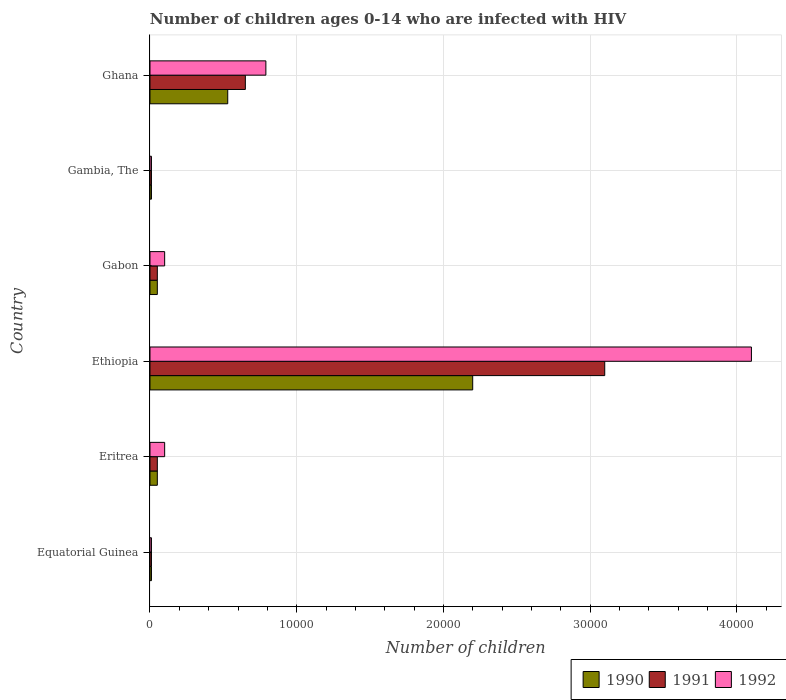How many different coloured bars are there?
Provide a short and direct response. 3. How many bars are there on the 3rd tick from the top?
Ensure brevity in your answer.  3. How many bars are there on the 6th tick from the bottom?
Your answer should be very brief. 3. What is the label of the 6th group of bars from the top?
Ensure brevity in your answer.  Equatorial Guinea. What is the number of HIV infected children in 1990 in Equatorial Guinea?
Give a very brief answer. 100. Across all countries, what is the maximum number of HIV infected children in 1992?
Your answer should be compact. 4.10e+04. Across all countries, what is the minimum number of HIV infected children in 1991?
Offer a terse response. 100. In which country was the number of HIV infected children in 1991 maximum?
Keep it short and to the point. Ethiopia. In which country was the number of HIV infected children in 1990 minimum?
Make the answer very short. Equatorial Guinea. What is the total number of HIV infected children in 1990 in the graph?
Provide a short and direct response. 2.85e+04. What is the difference between the number of HIV infected children in 1992 in Ethiopia and that in Ghana?
Give a very brief answer. 3.31e+04. What is the difference between the number of HIV infected children in 1992 in Gambia, The and the number of HIV infected children in 1991 in Ethiopia?
Ensure brevity in your answer.  -3.09e+04. What is the average number of HIV infected children in 1992 per country?
Your answer should be compact. 8516.67. What is the difference between the number of HIV infected children in 1990 and number of HIV infected children in 1992 in Equatorial Guinea?
Offer a terse response. 0. In how many countries, is the number of HIV infected children in 1991 greater than 26000 ?
Keep it short and to the point. 1. What is the ratio of the number of HIV infected children in 1990 in Equatorial Guinea to that in Eritrea?
Your answer should be very brief. 0.2. Is the number of HIV infected children in 1990 in Equatorial Guinea less than that in Gabon?
Ensure brevity in your answer.  Yes. What is the difference between the highest and the second highest number of HIV infected children in 1991?
Provide a succinct answer. 2.45e+04. What is the difference between the highest and the lowest number of HIV infected children in 1992?
Offer a terse response. 4.09e+04. Is the sum of the number of HIV infected children in 1990 in Eritrea and Ghana greater than the maximum number of HIV infected children in 1992 across all countries?
Give a very brief answer. No. How many bars are there?
Provide a succinct answer. 18. Are all the bars in the graph horizontal?
Make the answer very short. Yes. How many countries are there in the graph?
Your answer should be compact. 6. What is the difference between two consecutive major ticks on the X-axis?
Provide a short and direct response. 10000. Are the values on the major ticks of X-axis written in scientific E-notation?
Keep it short and to the point. No. Does the graph contain grids?
Your response must be concise. Yes. How are the legend labels stacked?
Give a very brief answer. Horizontal. What is the title of the graph?
Ensure brevity in your answer.  Number of children ages 0-14 who are infected with HIV. Does "2002" appear as one of the legend labels in the graph?
Your response must be concise. No. What is the label or title of the X-axis?
Ensure brevity in your answer.  Number of children. What is the label or title of the Y-axis?
Make the answer very short. Country. What is the Number of children of 1990 in Equatorial Guinea?
Provide a succinct answer. 100. What is the Number of children in 1992 in Equatorial Guinea?
Keep it short and to the point. 100. What is the Number of children in 1991 in Eritrea?
Offer a terse response. 500. What is the Number of children in 1990 in Ethiopia?
Give a very brief answer. 2.20e+04. What is the Number of children of 1991 in Ethiopia?
Offer a terse response. 3.10e+04. What is the Number of children in 1992 in Ethiopia?
Give a very brief answer. 4.10e+04. What is the Number of children in 1990 in Gabon?
Your response must be concise. 500. What is the Number of children in 1992 in Gabon?
Your response must be concise. 1000. What is the Number of children of 1990 in Gambia, The?
Give a very brief answer. 100. What is the Number of children in 1991 in Gambia, The?
Your answer should be compact. 100. What is the Number of children of 1992 in Gambia, The?
Provide a succinct answer. 100. What is the Number of children in 1990 in Ghana?
Give a very brief answer. 5300. What is the Number of children in 1991 in Ghana?
Keep it short and to the point. 6500. What is the Number of children of 1992 in Ghana?
Make the answer very short. 7900. Across all countries, what is the maximum Number of children in 1990?
Your answer should be very brief. 2.20e+04. Across all countries, what is the maximum Number of children of 1991?
Keep it short and to the point. 3.10e+04. Across all countries, what is the maximum Number of children of 1992?
Your answer should be compact. 4.10e+04. Across all countries, what is the minimum Number of children of 1990?
Offer a very short reply. 100. Across all countries, what is the minimum Number of children in 1991?
Ensure brevity in your answer.  100. Across all countries, what is the minimum Number of children of 1992?
Provide a succinct answer. 100. What is the total Number of children of 1990 in the graph?
Your answer should be compact. 2.85e+04. What is the total Number of children of 1991 in the graph?
Make the answer very short. 3.87e+04. What is the total Number of children of 1992 in the graph?
Provide a short and direct response. 5.11e+04. What is the difference between the Number of children of 1990 in Equatorial Guinea and that in Eritrea?
Offer a very short reply. -400. What is the difference between the Number of children of 1991 in Equatorial Guinea and that in Eritrea?
Offer a terse response. -400. What is the difference between the Number of children of 1992 in Equatorial Guinea and that in Eritrea?
Your response must be concise. -900. What is the difference between the Number of children of 1990 in Equatorial Guinea and that in Ethiopia?
Give a very brief answer. -2.19e+04. What is the difference between the Number of children in 1991 in Equatorial Guinea and that in Ethiopia?
Provide a short and direct response. -3.09e+04. What is the difference between the Number of children in 1992 in Equatorial Guinea and that in Ethiopia?
Offer a very short reply. -4.09e+04. What is the difference between the Number of children in 1990 in Equatorial Guinea and that in Gabon?
Make the answer very short. -400. What is the difference between the Number of children of 1991 in Equatorial Guinea and that in Gabon?
Your answer should be compact. -400. What is the difference between the Number of children in 1992 in Equatorial Guinea and that in Gabon?
Offer a terse response. -900. What is the difference between the Number of children in 1990 in Equatorial Guinea and that in Gambia, The?
Ensure brevity in your answer.  0. What is the difference between the Number of children of 1991 in Equatorial Guinea and that in Gambia, The?
Your answer should be compact. 0. What is the difference between the Number of children in 1990 in Equatorial Guinea and that in Ghana?
Keep it short and to the point. -5200. What is the difference between the Number of children in 1991 in Equatorial Guinea and that in Ghana?
Provide a short and direct response. -6400. What is the difference between the Number of children in 1992 in Equatorial Guinea and that in Ghana?
Offer a very short reply. -7800. What is the difference between the Number of children of 1990 in Eritrea and that in Ethiopia?
Your answer should be compact. -2.15e+04. What is the difference between the Number of children in 1991 in Eritrea and that in Ethiopia?
Offer a terse response. -3.05e+04. What is the difference between the Number of children in 1992 in Eritrea and that in Ethiopia?
Offer a very short reply. -4.00e+04. What is the difference between the Number of children of 1992 in Eritrea and that in Gabon?
Provide a short and direct response. 0. What is the difference between the Number of children in 1991 in Eritrea and that in Gambia, The?
Provide a short and direct response. 400. What is the difference between the Number of children of 1992 in Eritrea and that in Gambia, The?
Your answer should be very brief. 900. What is the difference between the Number of children of 1990 in Eritrea and that in Ghana?
Provide a succinct answer. -4800. What is the difference between the Number of children of 1991 in Eritrea and that in Ghana?
Provide a succinct answer. -6000. What is the difference between the Number of children in 1992 in Eritrea and that in Ghana?
Offer a very short reply. -6900. What is the difference between the Number of children of 1990 in Ethiopia and that in Gabon?
Ensure brevity in your answer.  2.15e+04. What is the difference between the Number of children of 1991 in Ethiopia and that in Gabon?
Ensure brevity in your answer.  3.05e+04. What is the difference between the Number of children in 1990 in Ethiopia and that in Gambia, The?
Provide a short and direct response. 2.19e+04. What is the difference between the Number of children in 1991 in Ethiopia and that in Gambia, The?
Your response must be concise. 3.09e+04. What is the difference between the Number of children in 1992 in Ethiopia and that in Gambia, The?
Your answer should be very brief. 4.09e+04. What is the difference between the Number of children in 1990 in Ethiopia and that in Ghana?
Your response must be concise. 1.67e+04. What is the difference between the Number of children in 1991 in Ethiopia and that in Ghana?
Make the answer very short. 2.45e+04. What is the difference between the Number of children of 1992 in Ethiopia and that in Ghana?
Provide a short and direct response. 3.31e+04. What is the difference between the Number of children of 1990 in Gabon and that in Gambia, The?
Your answer should be very brief. 400. What is the difference between the Number of children in 1992 in Gabon and that in Gambia, The?
Your response must be concise. 900. What is the difference between the Number of children in 1990 in Gabon and that in Ghana?
Ensure brevity in your answer.  -4800. What is the difference between the Number of children of 1991 in Gabon and that in Ghana?
Offer a very short reply. -6000. What is the difference between the Number of children in 1992 in Gabon and that in Ghana?
Provide a succinct answer. -6900. What is the difference between the Number of children in 1990 in Gambia, The and that in Ghana?
Make the answer very short. -5200. What is the difference between the Number of children of 1991 in Gambia, The and that in Ghana?
Offer a very short reply. -6400. What is the difference between the Number of children in 1992 in Gambia, The and that in Ghana?
Offer a very short reply. -7800. What is the difference between the Number of children of 1990 in Equatorial Guinea and the Number of children of 1991 in Eritrea?
Keep it short and to the point. -400. What is the difference between the Number of children of 1990 in Equatorial Guinea and the Number of children of 1992 in Eritrea?
Provide a succinct answer. -900. What is the difference between the Number of children of 1991 in Equatorial Guinea and the Number of children of 1992 in Eritrea?
Make the answer very short. -900. What is the difference between the Number of children of 1990 in Equatorial Guinea and the Number of children of 1991 in Ethiopia?
Offer a terse response. -3.09e+04. What is the difference between the Number of children in 1990 in Equatorial Guinea and the Number of children in 1992 in Ethiopia?
Your answer should be very brief. -4.09e+04. What is the difference between the Number of children of 1991 in Equatorial Guinea and the Number of children of 1992 in Ethiopia?
Offer a very short reply. -4.09e+04. What is the difference between the Number of children of 1990 in Equatorial Guinea and the Number of children of 1991 in Gabon?
Keep it short and to the point. -400. What is the difference between the Number of children of 1990 in Equatorial Guinea and the Number of children of 1992 in Gabon?
Keep it short and to the point. -900. What is the difference between the Number of children of 1991 in Equatorial Guinea and the Number of children of 1992 in Gabon?
Keep it short and to the point. -900. What is the difference between the Number of children of 1991 in Equatorial Guinea and the Number of children of 1992 in Gambia, The?
Offer a terse response. 0. What is the difference between the Number of children of 1990 in Equatorial Guinea and the Number of children of 1991 in Ghana?
Make the answer very short. -6400. What is the difference between the Number of children of 1990 in Equatorial Guinea and the Number of children of 1992 in Ghana?
Offer a very short reply. -7800. What is the difference between the Number of children in 1991 in Equatorial Guinea and the Number of children in 1992 in Ghana?
Make the answer very short. -7800. What is the difference between the Number of children in 1990 in Eritrea and the Number of children in 1991 in Ethiopia?
Offer a very short reply. -3.05e+04. What is the difference between the Number of children of 1990 in Eritrea and the Number of children of 1992 in Ethiopia?
Your answer should be compact. -4.05e+04. What is the difference between the Number of children in 1991 in Eritrea and the Number of children in 1992 in Ethiopia?
Provide a short and direct response. -4.05e+04. What is the difference between the Number of children of 1990 in Eritrea and the Number of children of 1991 in Gabon?
Ensure brevity in your answer.  0. What is the difference between the Number of children of 1990 in Eritrea and the Number of children of 1992 in Gabon?
Give a very brief answer. -500. What is the difference between the Number of children in 1991 in Eritrea and the Number of children in 1992 in Gabon?
Keep it short and to the point. -500. What is the difference between the Number of children in 1991 in Eritrea and the Number of children in 1992 in Gambia, The?
Your response must be concise. 400. What is the difference between the Number of children in 1990 in Eritrea and the Number of children in 1991 in Ghana?
Ensure brevity in your answer.  -6000. What is the difference between the Number of children in 1990 in Eritrea and the Number of children in 1992 in Ghana?
Your answer should be very brief. -7400. What is the difference between the Number of children of 1991 in Eritrea and the Number of children of 1992 in Ghana?
Your answer should be very brief. -7400. What is the difference between the Number of children of 1990 in Ethiopia and the Number of children of 1991 in Gabon?
Make the answer very short. 2.15e+04. What is the difference between the Number of children of 1990 in Ethiopia and the Number of children of 1992 in Gabon?
Your answer should be compact. 2.10e+04. What is the difference between the Number of children of 1990 in Ethiopia and the Number of children of 1991 in Gambia, The?
Your response must be concise. 2.19e+04. What is the difference between the Number of children in 1990 in Ethiopia and the Number of children in 1992 in Gambia, The?
Make the answer very short. 2.19e+04. What is the difference between the Number of children in 1991 in Ethiopia and the Number of children in 1992 in Gambia, The?
Offer a very short reply. 3.09e+04. What is the difference between the Number of children of 1990 in Ethiopia and the Number of children of 1991 in Ghana?
Give a very brief answer. 1.55e+04. What is the difference between the Number of children in 1990 in Ethiopia and the Number of children in 1992 in Ghana?
Your response must be concise. 1.41e+04. What is the difference between the Number of children in 1991 in Ethiopia and the Number of children in 1992 in Ghana?
Your answer should be very brief. 2.31e+04. What is the difference between the Number of children in 1991 in Gabon and the Number of children in 1992 in Gambia, The?
Your answer should be very brief. 400. What is the difference between the Number of children of 1990 in Gabon and the Number of children of 1991 in Ghana?
Make the answer very short. -6000. What is the difference between the Number of children in 1990 in Gabon and the Number of children in 1992 in Ghana?
Your answer should be compact. -7400. What is the difference between the Number of children of 1991 in Gabon and the Number of children of 1992 in Ghana?
Your answer should be compact. -7400. What is the difference between the Number of children in 1990 in Gambia, The and the Number of children in 1991 in Ghana?
Your response must be concise. -6400. What is the difference between the Number of children in 1990 in Gambia, The and the Number of children in 1992 in Ghana?
Your answer should be very brief. -7800. What is the difference between the Number of children of 1991 in Gambia, The and the Number of children of 1992 in Ghana?
Ensure brevity in your answer.  -7800. What is the average Number of children of 1990 per country?
Provide a succinct answer. 4750. What is the average Number of children of 1991 per country?
Ensure brevity in your answer.  6450. What is the average Number of children in 1992 per country?
Provide a short and direct response. 8516.67. What is the difference between the Number of children of 1990 and Number of children of 1992 in Equatorial Guinea?
Offer a terse response. 0. What is the difference between the Number of children in 1991 and Number of children in 1992 in Equatorial Guinea?
Ensure brevity in your answer.  0. What is the difference between the Number of children in 1990 and Number of children in 1992 in Eritrea?
Provide a short and direct response. -500. What is the difference between the Number of children in 1991 and Number of children in 1992 in Eritrea?
Provide a short and direct response. -500. What is the difference between the Number of children of 1990 and Number of children of 1991 in Ethiopia?
Provide a short and direct response. -9000. What is the difference between the Number of children of 1990 and Number of children of 1992 in Ethiopia?
Your answer should be compact. -1.90e+04. What is the difference between the Number of children in 1990 and Number of children in 1991 in Gabon?
Provide a succinct answer. 0. What is the difference between the Number of children of 1990 and Number of children of 1992 in Gabon?
Offer a terse response. -500. What is the difference between the Number of children in 1991 and Number of children in 1992 in Gabon?
Give a very brief answer. -500. What is the difference between the Number of children in 1990 and Number of children in 1992 in Gambia, The?
Make the answer very short. 0. What is the difference between the Number of children of 1990 and Number of children of 1991 in Ghana?
Your answer should be compact. -1200. What is the difference between the Number of children in 1990 and Number of children in 1992 in Ghana?
Give a very brief answer. -2600. What is the difference between the Number of children in 1991 and Number of children in 1992 in Ghana?
Give a very brief answer. -1400. What is the ratio of the Number of children of 1991 in Equatorial Guinea to that in Eritrea?
Make the answer very short. 0.2. What is the ratio of the Number of children of 1992 in Equatorial Guinea to that in Eritrea?
Make the answer very short. 0.1. What is the ratio of the Number of children in 1990 in Equatorial Guinea to that in Ethiopia?
Your answer should be very brief. 0. What is the ratio of the Number of children in 1991 in Equatorial Guinea to that in Ethiopia?
Make the answer very short. 0. What is the ratio of the Number of children in 1992 in Equatorial Guinea to that in Ethiopia?
Give a very brief answer. 0. What is the ratio of the Number of children of 1991 in Equatorial Guinea to that in Gabon?
Your answer should be compact. 0.2. What is the ratio of the Number of children in 1990 in Equatorial Guinea to that in Gambia, The?
Offer a terse response. 1. What is the ratio of the Number of children in 1990 in Equatorial Guinea to that in Ghana?
Your answer should be compact. 0.02. What is the ratio of the Number of children in 1991 in Equatorial Guinea to that in Ghana?
Give a very brief answer. 0.02. What is the ratio of the Number of children of 1992 in Equatorial Guinea to that in Ghana?
Make the answer very short. 0.01. What is the ratio of the Number of children in 1990 in Eritrea to that in Ethiopia?
Provide a short and direct response. 0.02. What is the ratio of the Number of children of 1991 in Eritrea to that in Ethiopia?
Give a very brief answer. 0.02. What is the ratio of the Number of children in 1992 in Eritrea to that in Ethiopia?
Provide a short and direct response. 0.02. What is the ratio of the Number of children in 1990 in Eritrea to that in Gabon?
Your answer should be compact. 1. What is the ratio of the Number of children of 1990 in Eritrea to that in Ghana?
Give a very brief answer. 0.09. What is the ratio of the Number of children of 1991 in Eritrea to that in Ghana?
Offer a very short reply. 0.08. What is the ratio of the Number of children in 1992 in Eritrea to that in Ghana?
Offer a terse response. 0.13. What is the ratio of the Number of children in 1992 in Ethiopia to that in Gabon?
Make the answer very short. 41. What is the ratio of the Number of children of 1990 in Ethiopia to that in Gambia, The?
Your response must be concise. 220. What is the ratio of the Number of children of 1991 in Ethiopia to that in Gambia, The?
Offer a very short reply. 310. What is the ratio of the Number of children in 1992 in Ethiopia to that in Gambia, The?
Make the answer very short. 410. What is the ratio of the Number of children in 1990 in Ethiopia to that in Ghana?
Your response must be concise. 4.15. What is the ratio of the Number of children in 1991 in Ethiopia to that in Ghana?
Your answer should be very brief. 4.77. What is the ratio of the Number of children of 1992 in Ethiopia to that in Ghana?
Provide a succinct answer. 5.19. What is the ratio of the Number of children in 1990 in Gabon to that in Gambia, The?
Provide a succinct answer. 5. What is the ratio of the Number of children in 1992 in Gabon to that in Gambia, The?
Ensure brevity in your answer.  10. What is the ratio of the Number of children of 1990 in Gabon to that in Ghana?
Provide a short and direct response. 0.09. What is the ratio of the Number of children of 1991 in Gabon to that in Ghana?
Give a very brief answer. 0.08. What is the ratio of the Number of children of 1992 in Gabon to that in Ghana?
Provide a short and direct response. 0.13. What is the ratio of the Number of children of 1990 in Gambia, The to that in Ghana?
Your response must be concise. 0.02. What is the ratio of the Number of children in 1991 in Gambia, The to that in Ghana?
Give a very brief answer. 0.02. What is the ratio of the Number of children in 1992 in Gambia, The to that in Ghana?
Offer a terse response. 0.01. What is the difference between the highest and the second highest Number of children of 1990?
Keep it short and to the point. 1.67e+04. What is the difference between the highest and the second highest Number of children in 1991?
Your answer should be compact. 2.45e+04. What is the difference between the highest and the second highest Number of children in 1992?
Your answer should be compact. 3.31e+04. What is the difference between the highest and the lowest Number of children in 1990?
Keep it short and to the point. 2.19e+04. What is the difference between the highest and the lowest Number of children of 1991?
Make the answer very short. 3.09e+04. What is the difference between the highest and the lowest Number of children of 1992?
Your response must be concise. 4.09e+04. 